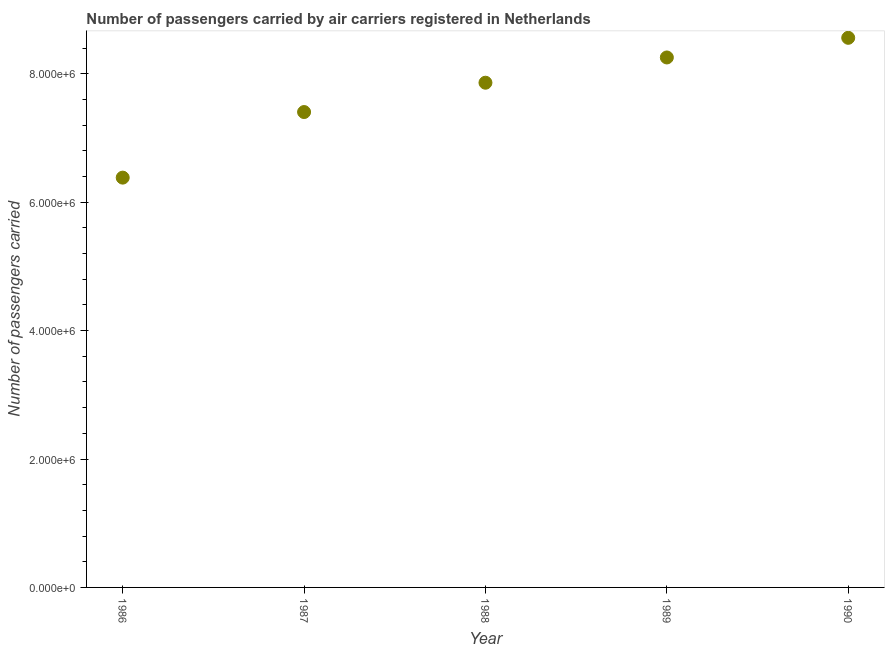What is the number of passengers carried in 1988?
Make the answer very short. 7.86e+06. Across all years, what is the maximum number of passengers carried?
Give a very brief answer. 8.56e+06. Across all years, what is the minimum number of passengers carried?
Offer a terse response. 6.38e+06. What is the sum of the number of passengers carried?
Provide a short and direct response. 3.85e+07. What is the difference between the number of passengers carried in 1988 and 1989?
Offer a very short reply. -3.93e+05. What is the average number of passengers carried per year?
Provide a succinct answer. 7.69e+06. What is the median number of passengers carried?
Give a very brief answer. 7.86e+06. In how many years, is the number of passengers carried greater than 3200000 ?
Provide a succinct answer. 5. What is the ratio of the number of passengers carried in 1987 to that in 1989?
Your response must be concise. 0.9. What is the difference between the highest and the second highest number of passengers carried?
Provide a succinct answer. 3.06e+05. Is the sum of the number of passengers carried in 1987 and 1989 greater than the maximum number of passengers carried across all years?
Offer a terse response. Yes. What is the difference between the highest and the lowest number of passengers carried?
Give a very brief answer. 2.18e+06. In how many years, is the number of passengers carried greater than the average number of passengers carried taken over all years?
Ensure brevity in your answer.  3. Does the number of passengers carried monotonically increase over the years?
Provide a succinct answer. Yes. Does the graph contain grids?
Your answer should be compact. No. What is the title of the graph?
Provide a short and direct response. Number of passengers carried by air carriers registered in Netherlands. What is the label or title of the Y-axis?
Provide a short and direct response. Number of passengers carried. What is the Number of passengers carried in 1986?
Provide a short and direct response. 6.38e+06. What is the Number of passengers carried in 1987?
Your answer should be compact. 7.40e+06. What is the Number of passengers carried in 1988?
Your response must be concise. 7.86e+06. What is the Number of passengers carried in 1989?
Your answer should be very brief. 8.25e+06. What is the Number of passengers carried in 1990?
Give a very brief answer. 8.56e+06. What is the difference between the Number of passengers carried in 1986 and 1987?
Your response must be concise. -1.02e+06. What is the difference between the Number of passengers carried in 1986 and 1988?
Make the answer very short. -1.48e+06. What is the difference between the Number of passengers carried in 1986 and 1989?
Provide a succinct answer. -1.87e+06. What is the difference between the Number of passengers carried in 1986 and 1990?
Your answer should be compact. -2.18e+06. What is the difference between the Number of passengers carried in 1987 and 1988?
Your answer should be compact. -4.57e+05. What is the difference between the Number of passengers carried in 1987 and 1989?
Provide a short and direct response. -8.50e+05. What is the difference between the Number of passengers carried in 1987 and 1990?
Your answer should be compact. -1.16e+06. What is the difference between the Number of passengers carried in 1988 and 1989?
Ensure brevity in your answer.  -3.93e+05. What is the difference between the Number of passengers carried in 1988 and 1990?
Provide a short and direct response. -6.99e+05. What is the difference between the Number of passengers carried in 1989 and 1990?
Make the answer very short. -3.06e+05. What is the ratio of the Number of passengers carried in 1986 to that in 1987?
Your answer should be compact. 0.86. What is the ratio of the Number of passengers carried in 1986 to that in 1988?
Offer a terse response. 0.81. What is the ratio of the Number of passengers carried in 1986 to that in 1989?
Provide a short and direct response. 0.77. What is the ratio of the Number of passengers carried in 1986 to that in 1990?
Provide a succinct answer. 0.75. What is the ratio of the Number of passengers carried in 1987 to that in 1988?
Your answer should be very brief. 0.94. What is the ratio of the Number of passengers carried in 1987 to that in 1989?
Your response must be concise. 0.9. What is the ratio of the Number of passengers carried in 1987 to that in 1990?
Ensure brevity in your answer.  0.86. What is the ratio of the Number of passengers carried in 1988 to that in 1989?
Give a very brief answer. 0.95. What is the ratio of the Number of passengers carried in 1988 to that in 1990?
Your response must be concise. 0.92. What is the ratio of the Number of passengers carried in 1989 to that in 1990?
Provide a succinct answer. 0.96. 